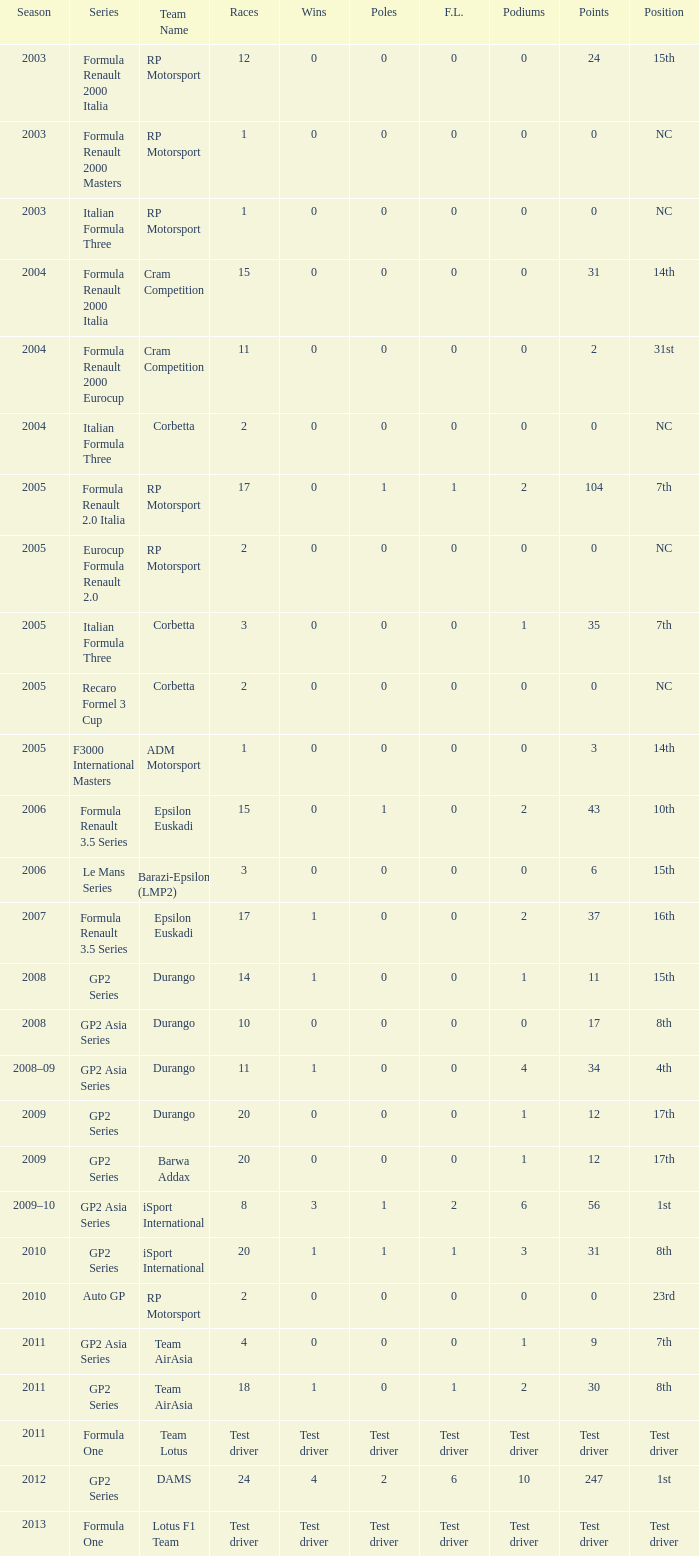In four races, what is the total number of poles? 0.0. 